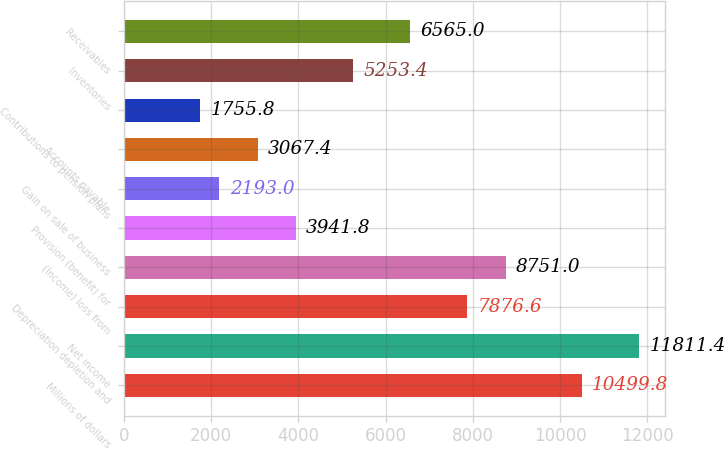Convert chart. <chart><loc_0><loc_0><loc_500><loc_500><bar_chart><fcel>Millions of dollars<fcel>Net income<fcel>Depreciation depletion and<fcel>(Income) loss from<fcel>Provision (benefit) for<fcel>Gain on sale of business<fcel>Accounts payable<fcel>Contributions to pension plans<fcel>Inventories<fcel>Receivables<nl><fcel>10499.8<fcel>11811.4<fcel>7876.6<fcel>8751<fcel>3941.8<fcel>2193<fcel>3067.4<fcel>1755.8<fcel>5253.4<fcel>6565<nl></chart> 